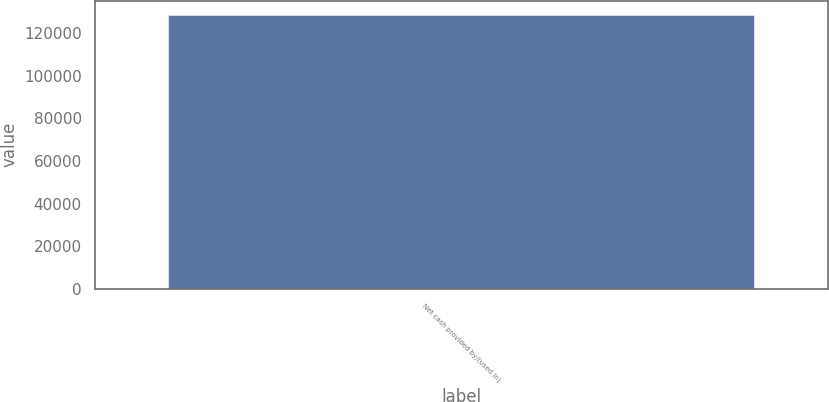Convert chart to OTSL. <chart><loc_0><loc_0><loc_500><loc_500><bar_chart><fcel>Net cash provided by/(used in)<nl><fcel>128846<nl></chart> 